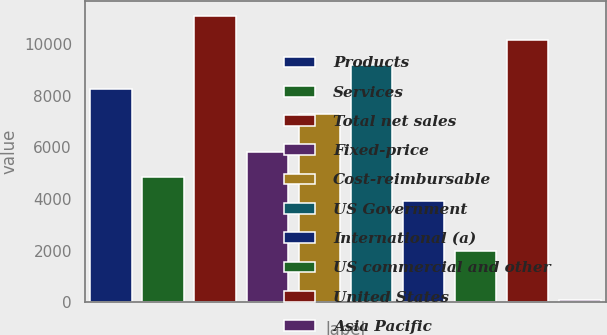<chart> <loc_0><loc_0><loc_500><loc_500><bar_chart><fcel>Products<fcel>Services<fcel>Total net sales<fcel>Fixed-price<fcel>Cost-reimbursable<fcel>US Government<fcel>International (a)<fcel>US commercial and other<fcel>United States<fcel>Asia Pacific<nl><fcel>8240.5<fcel>4855.5<fcel>11095<fcel>5807<fcel>7289<fcel>9192<fcel>3904<fcel>2001<fcel>10143.5<fcel>98<nl></chart> 